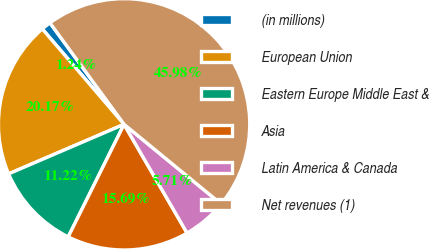Convert chart to OTSL. <chart><loc_0><loc_0><loc_500><loc_500><pie_chart><fcel>(in millions)<fcel>European Union<fcel>Eastern Europe Middle East &<fcel>Asia<fcel>Latin America & Canada<fcel>Net revenues (1)<nl><fcel>1.24%<fcel>20.17%<fcel>11.22%<fcel>15.69%<fcel>5.71%<fcel>45.98%<nl></chart> 